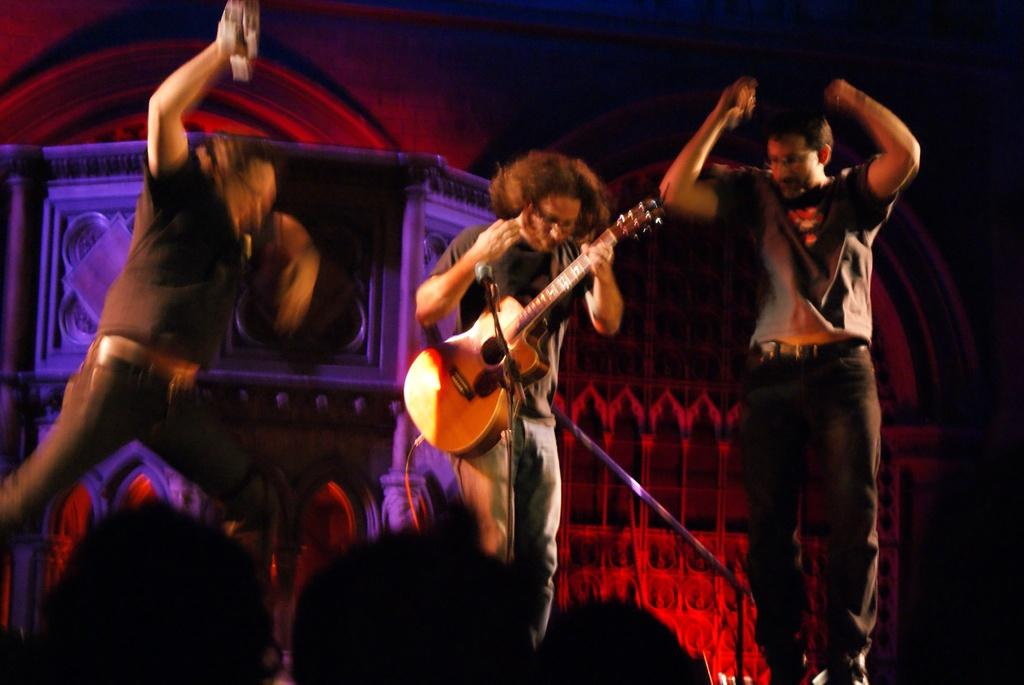What is the man in the image holding? The man is holding a guitar in the image. What are the other two men doing in the image? The other two men are dancing in the image. What object is present for amplifying sound? There is a microphone in the image. Can you describe the presence of other people in the image? There are other people present in the image. What type of balls are being juggled by the man with the guitar in the image? There are no balls present in the image, and the man with the guitar is not juggling anything. 